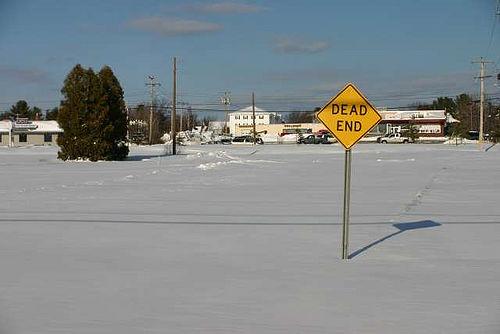Are there any cars on the street?
Concise answer only. No. What does the diamond shaped sign say?
Keep it brief. Dead end. What is the yellow object?
Quick response, please. Sign. What does the yellow sign say?
Short answer required. Dead end. In what direction is the traffic sign shadow?
Keep it brief. Right. What does the sign say?
Be succinct. Dead end. Has the snow been walked on?
Give a very brief answer. Yes. Is this a stop sign?
Write a very short answer. No. Why does the sign appear to stick up from nowhere?
Keep it brief. Snow. 